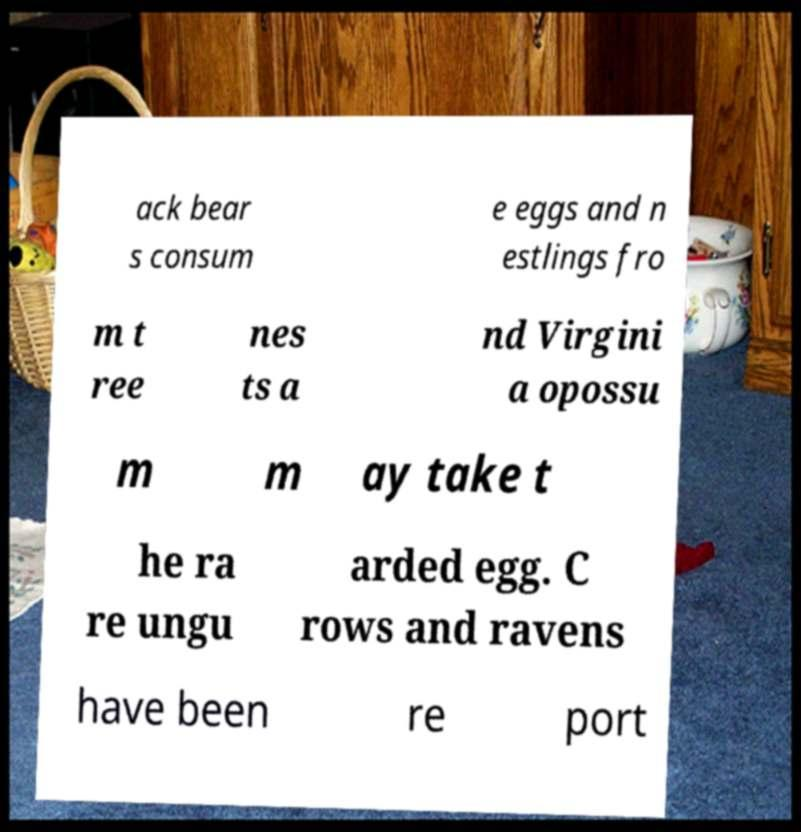Could you assist in decoding the text presented in this image and type it out clearly? ack bear s consum e eggs and n estlings fro m t ree nes ts a nd Virgini a opossu m m ay take t he ra re ungu arded egg. C rows and ravens have been re port 